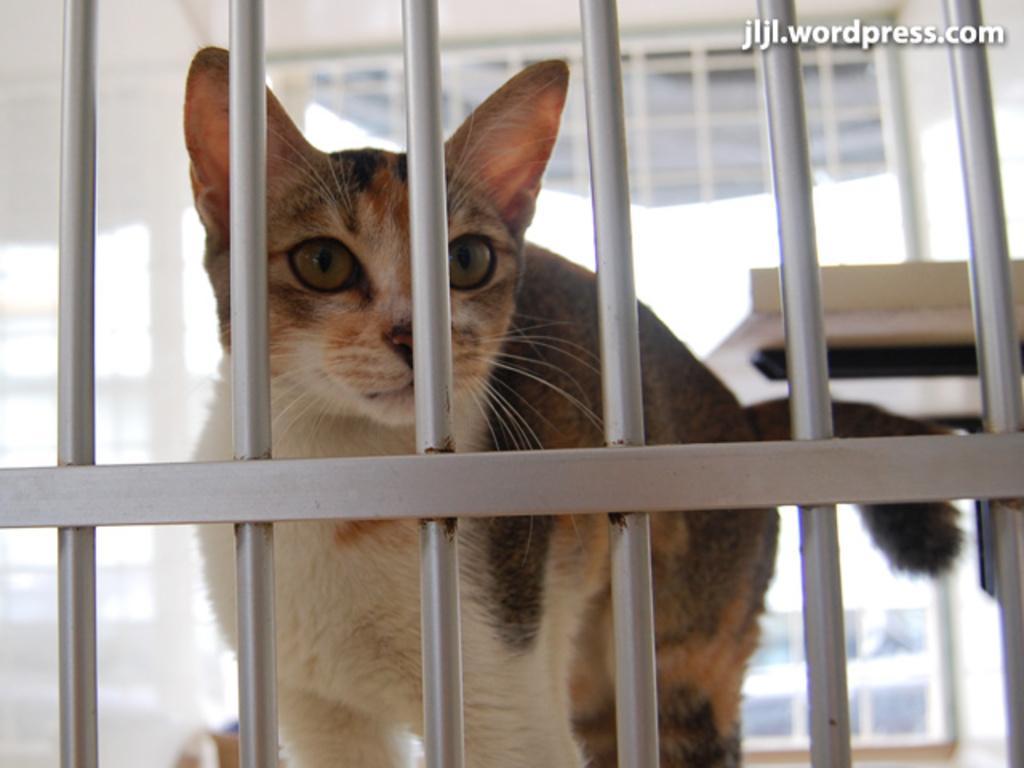Can you describe this image briefly? In the center of the image a cat is there. In the background of the image grills are there. At the top of the image window is there. On the right side of the image table is there. 